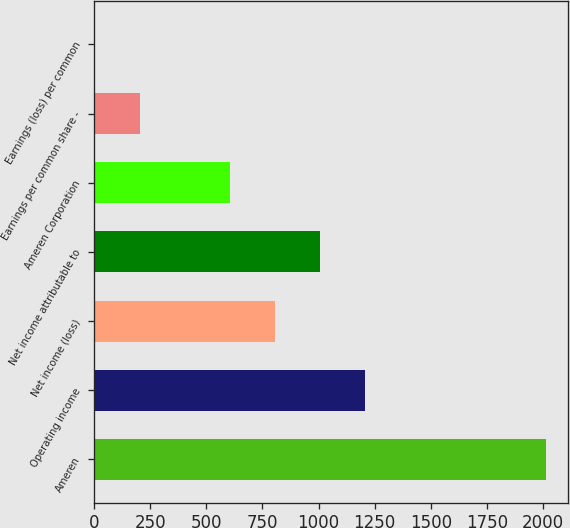Convert chart to OTSL. <chart><loc_0><loc_0><loc_500><loc_500><bar_chart><fcel>Ameren<fcel>Operating income<fcel>Net income (loss)<fcel>Net income attributable to<fcel>Ameren Corporation<fcel>Earnings per common share -<fcel>Earnings (loss) per common<nl><fcel>2013<fcel>1208.31<fcel>805.96<fcel>1007.13<fcel>604.79<fcel>202.43<fcel>1.25<nl></chart> 